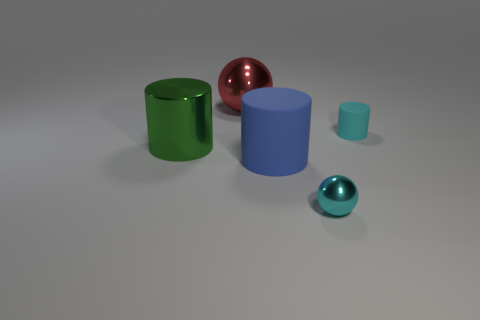What size is the blue cylinder that is made of the same material as the small cyan cylinder? The blue cylinder, constructed of the same reflective material as the small cyan cylinder, is considerably larger in size. Judging by the proportion of the objects in the image, the blue cylinder's height appears to be approximately twice that of the small cyan cylinder, and its diameter is notably wider. 